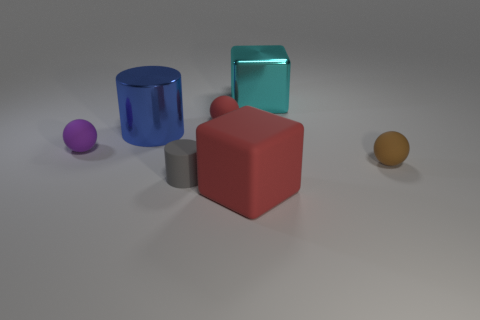Is there anything else that is the same color as the shiny cube?
Offer a terse response. No. What shape is the big metallic thing that is in front of the red matte sphere?
Your response must be concise. Cylinder. There is a tiny thing that is on the left side of the big matte object and in front of the small purple rubber object; what is its shape?
Offer a very short reply. Cylinder. What number of purple things are either spheres or small rubber objects?
Your answer should be compact. 1. There is a tiny matte ball that is behind the blue cylinder; is it the same color as the rubber block?
Ensure brevity in your answer.  Yes. There is a red thing that is right of the ball that is behind the blue shiny cylinder; what size is it?
Keep it short and to the point. Large. There is a cyan cube that is the same size as the blue cylinder; what material is it?
Give a very brief answer. Metal. How many other objects are the same size as the shiny block?
Provide a short and direct response. 2. How many cubes are either cyan rubber things or red rubber things?
Offer a terse response. 1. There is a block that is behind the small matte object in front of the tiny rubber thing that is to the right of the large red rubber block; what is its material?
Provide a succinct answer. Metal. 